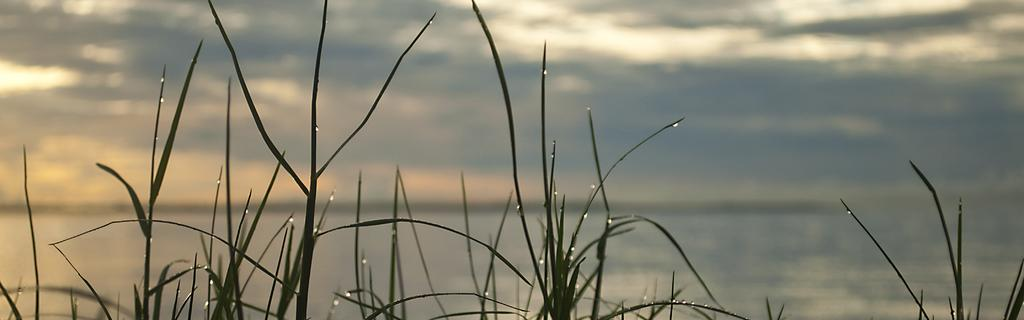What type of living organisms can be seen in the image? Plants can be seen in the image. What else is visible in the image besides the plants? Water and the sky are visible in the image. Can you tell if the image was taken during the day or night? The image was likely taken during the day, as the sky is visible. What type of seed can be seen sprouting in the image? There is no seed visible in the image, as it only shows plants, water, and the sky. 